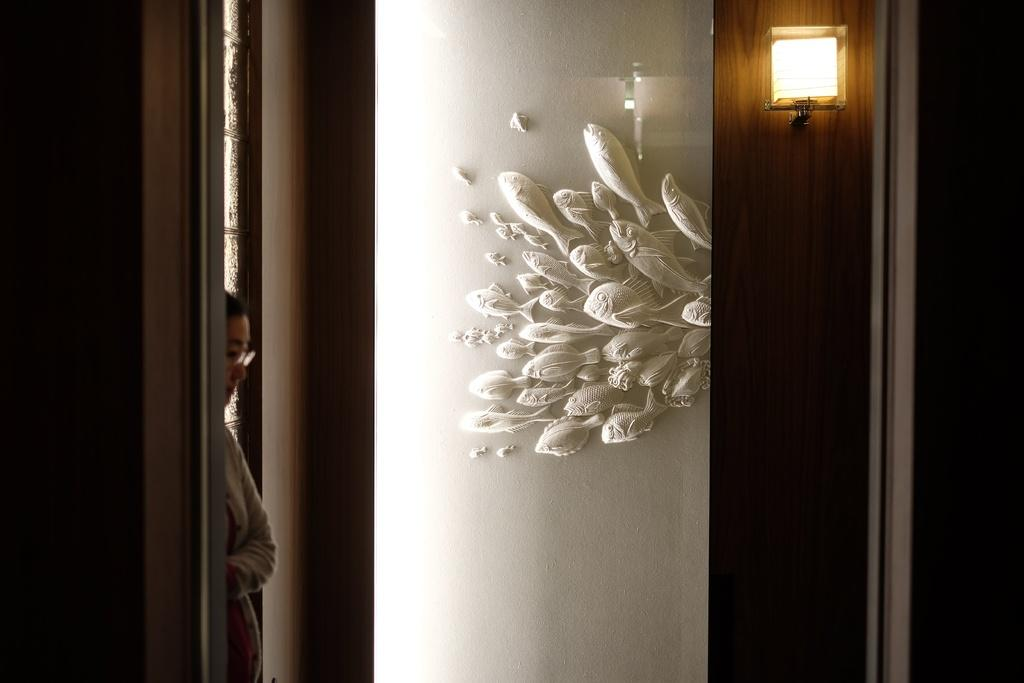Who is present in the image? There is a woman in the image. What is the woman wearing on her face? The woman is wearing spectacles. What can be seen behind the woman? There is a wall in the image. What is providing illumination in the image? There is a light in the image. What type of animals can be seen in the image? There are fishes in the image. What type of stone can be seen in the image? There is no stone present in the image. What breed of dog is visible in the image? There is no dog present in the image. 